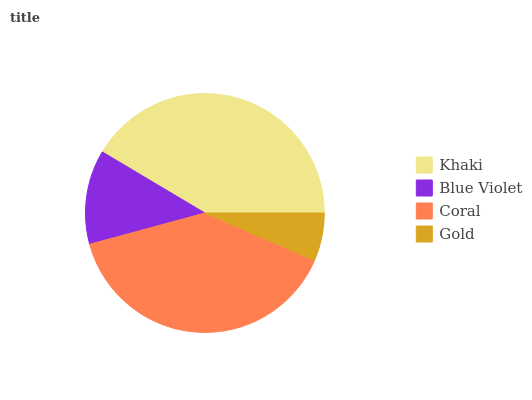Is Gold the minimum?
Answer yes or no. Yes. Is Khaki the maximum?
Answer yes or no. Yes. Is Blue Violet the minimum?
Answer yes or no. No. Is Blue Violet the maximum?
Answer yes or no. No. Is Khaki greater than Blue Violet?
Answer yes or no. Yes. Is Blue Violet less than Khaki?
Answer yes or no. Yes. Is Blue Violet greater than Khaki?
Answer yes or no. No. Is Khaki less than Blue Violet?
Answer yes or no. No. Is Coral the high median?
Answer yes or no. Yes. Is Blue Violet the low median?
Answer yes or no. Yes. Is Gold the high median?
Answer yes or no. No. Is Gold the low median?
Answer yes or no. No. 